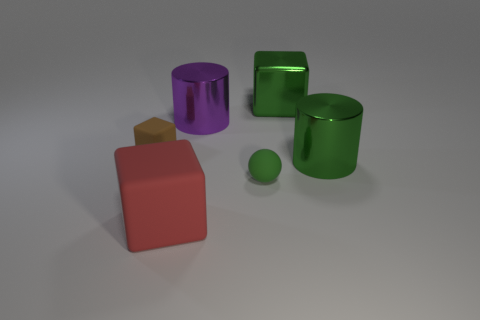There is a rubber ball that is the same color as the big metallic block; what is its size?
Offer a terse response. Small. Is there anything else that has the same color as the metal cube?
Provide a succinct answer. Yes. What material is the big thing that is on the right side of the metal cube behind the small green matte sphere?
Keep it short and to the point. Metal. Do the large purple object and the big block that is in front of the large purple shiny thing have the same material?
Offer a terse response. No. How many things are large cubes that are behind the large red cube or large green metal cylinders?
Offer a terse response. 2. Is there a cylinder of the same color as the tiny rubber block?
Offer a very short reply. No. There is a brown object; does it have the same shape as the big object in front of the small sphere?
Give a very brief answer. Yes. What number of tiny objects are behind the rubber sphere and right of the large red block?
Ensure brevity in your answer.  0. There is a big red thing that is the same shape as the small brown rubber object; what is its material?
Offer a very short reply. Rubber. What is the size of the green object that is in front of the large green shiny cylinder that is to the right of the tiny ball?
Offer a terse response. Small. 